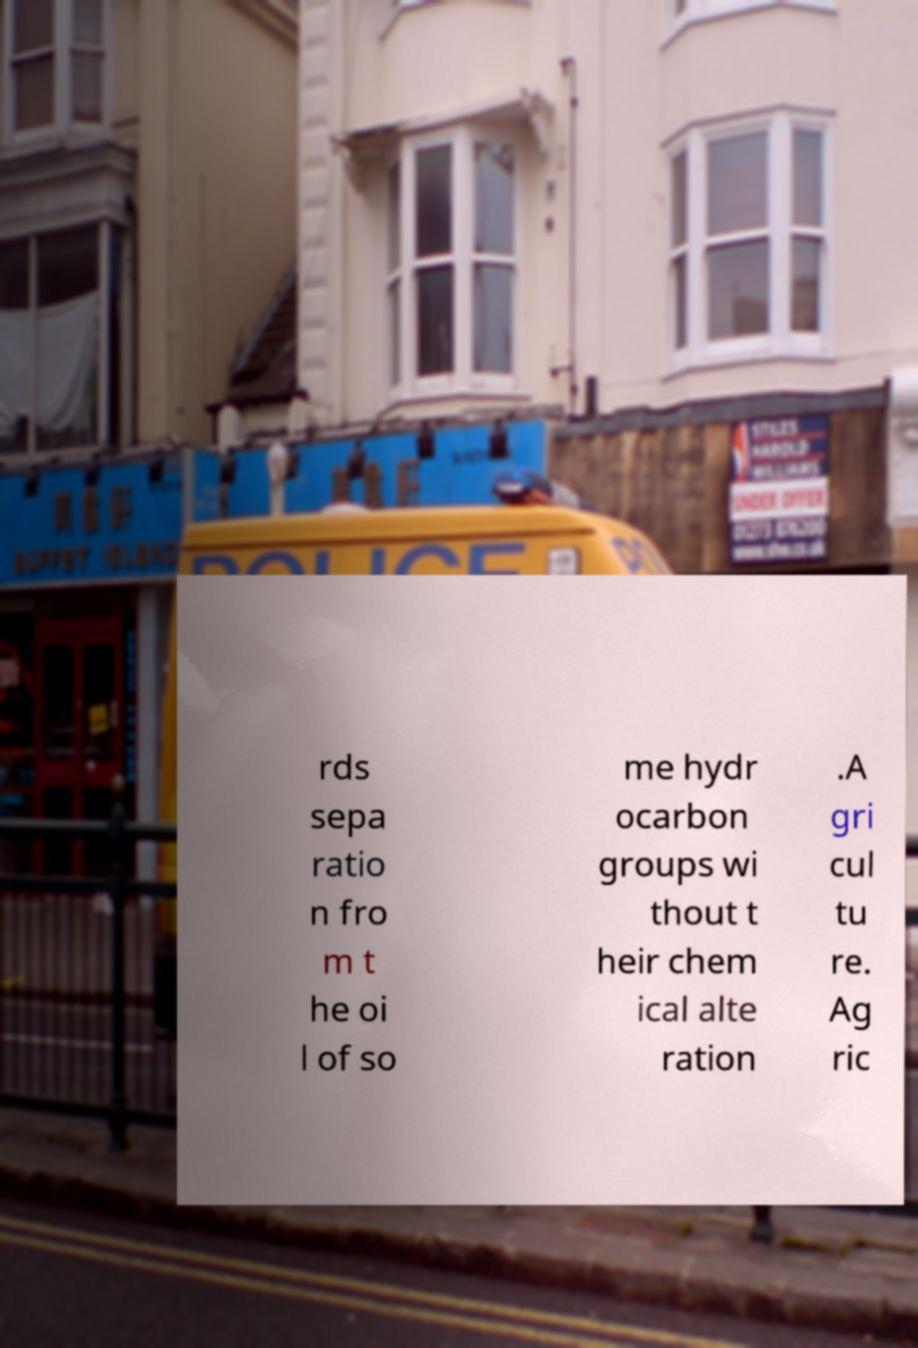Can you read and provide the text displayed in the image?This photo seems to have some interesting text. Can you extract and type it out for me? rds sepa ratio n fro m t he oi l of so me hydr ocarbon groups wi thout t heir chem ical alte ration .A gri cul tu re. Ag ric 